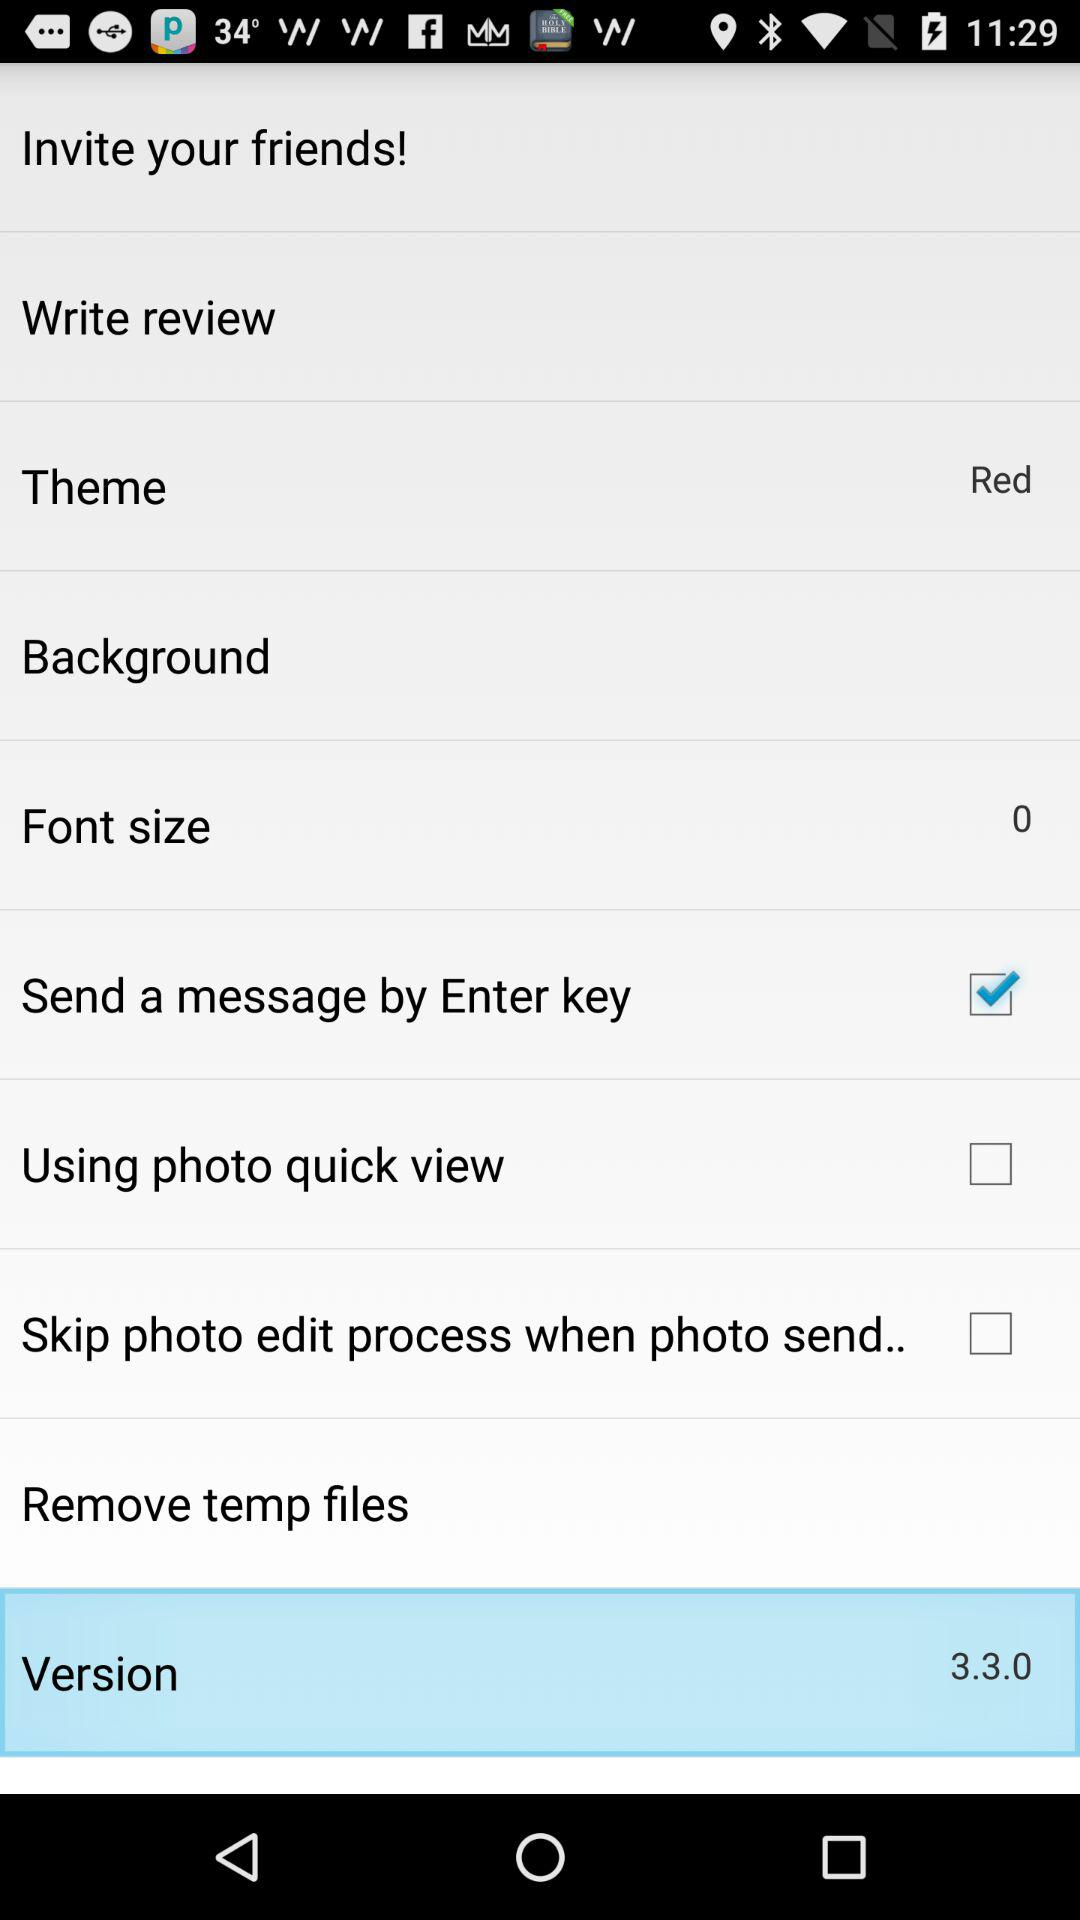What is the version of the application being used? The version is 3.3.0. 